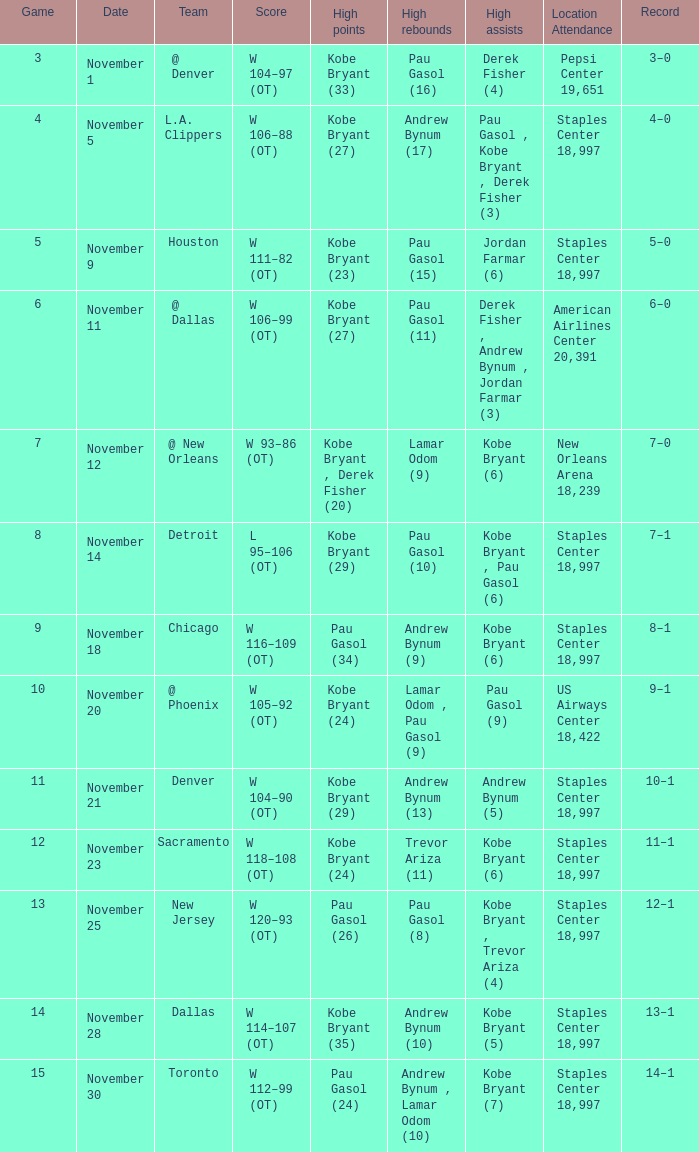What is high assists, when high scores is "kobe bryant (27)", and when high rebounds is "pau gasol (11)"? Derek Fisher , Andrew Bynum , Jordan Farmar (3). 